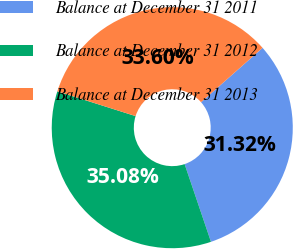<chart> <loc_0><loc_0><loc_500><loc_500><pie_chart><fcel>Balance at December 31 2011<fcel>Balance at December 31 2012<fcel>Balance at December 31 2013<nl><fcel>31.32%<fcel>35.08%<fcel>33.6%<nl></chart> 